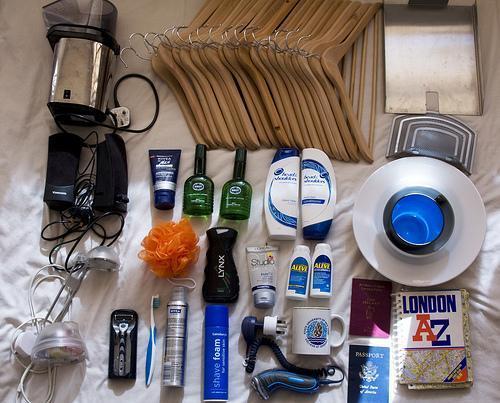How many maps of london are there?
Give a very brief answer. 1. How many orange abth products are in the picture?
Give a very brief answer. 1. 